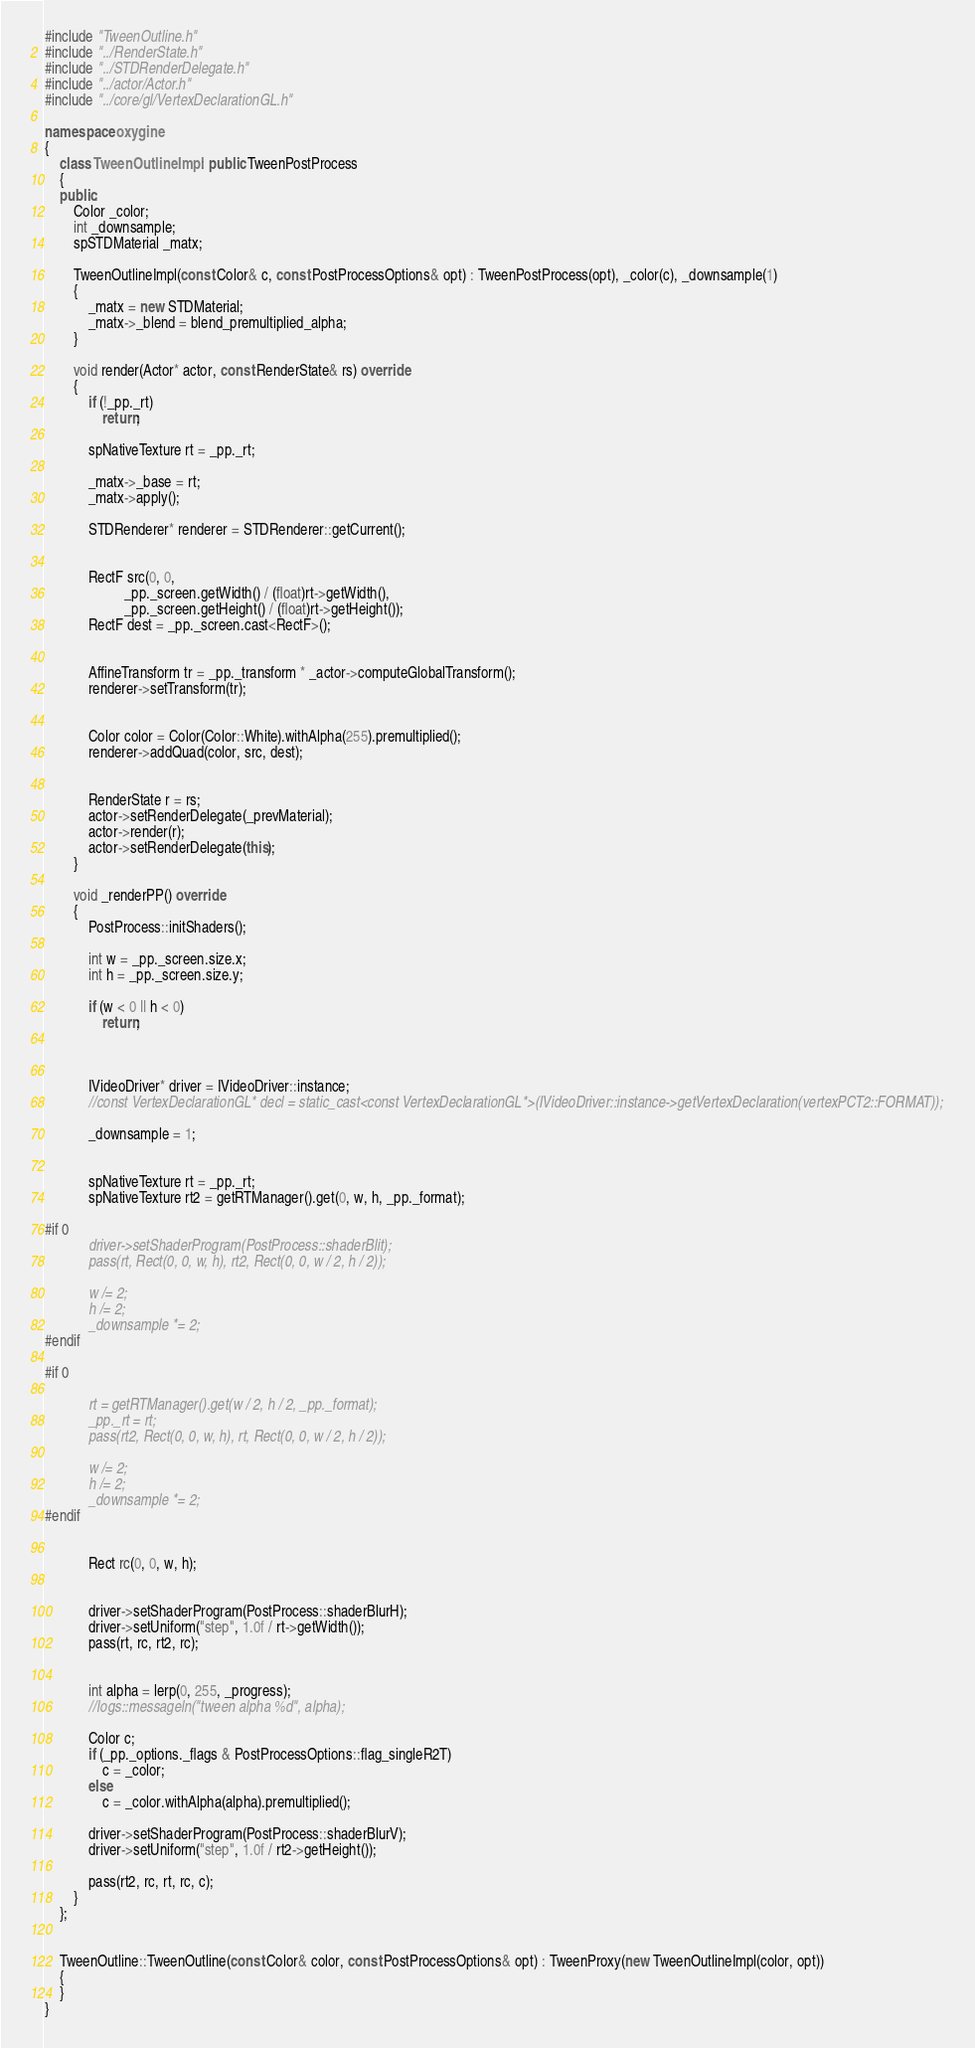<code> <loc_0><loc_0><loc_500><loc_500><_C++_>#include "TweenOutline.h"
#include "../RenderState.h"
#include "../STDRenderDelegate.h"
#include "../actor/Actor.h"
#include "../core/gl/VertexDeclarationGL.h"

namespace oxygine
{
    class TweenOutlineImpl : public TweenPostProcess
    {
    public:
        Color _color;
        int _downsample;
        spSTDMaterial _matx;

        TweenOutlineImpl(const Color& c, const PostProcessOptions& opt) : TweenPostProcess(opt), _color(c), _downsample(1)
        {
            _matx = new STDMaterial;
            _matx->_blend = blend_premultiplied_alpha;
        }

        void render(Actor* actor, const RenderState& rs) override
        {
            if (!_pp._rt)
                return;

            spNativeTexture rt = _pp._rt;

            _matx->_base = rt;
            _matx->apply();

            STDRenderer* renderer = STDRenderer::getCurrent();


            RectF src(0, 0,
                      _pp._screen.getWidth() / (float)rt->getWidth(),
                      _pp._screen.getHeight() / (float)rt->getHeight());
            RectF dest = _pp._screen.cast<RectF>();


            AffineTransform tr = _pp._transform * _actor->computeGlobalTransform();
            renderer->setTransform(tr);


            Color color = Color(Color::White).withAlpha(255).premultiplied();
            renderer->addQuad(color, src, dest);


            RenderState r = rs;
            actor->setRenderDelegate(_prevMaterial);
            actor->render(r);
            actor->setRenderDelegate(this);
        }

        void _renderPP() override
        {
            PostProcess::initShaders();

            int w = _pp._screen.size.x;
            int h = _pp._screen.size.y;

            if (w < 0 || h < 0)
                return;



            IVideoDriver* driver = IVideoDriver::instance;
            //const VertexDeclarationGL* decl = static_cast<const VertexDeclarationGL*>(IVideoDriver::instance->getVertexDeclaration(vertexPCT2::FORMAT));

            _downsample = 1;


            spNativeTexture rt = _pp._rt;
            spNativeTexture rt2 = getRTManager().get(0, w, h, _pp._format);

#if 0
            driver->setShaderProgram(PostProcess::shaderBlit);
            pass(rt, Rect(0, 0, w, h), rt2, Rect(0, 0, w / 2, h / 2));

            w /= 2;
            h /= 2;
            _downsample *= 2;
#endif

#if 0

            rt = getRTManager().get(w / 2, h / 2, _pp._format);
            _pp._rt = rt;
            pass(rt2, Rect(0, 0, w, h), rt, Rect(0, 0, w / 2, h / 2));

            w /= 2;
            h /= 2;
            _downsample *= 2;
#endif


            Rect rc(0, 0, w, h);


            driver->setShaderProgram(PostProcess::shaderBlurH);
            driver->setUniform("step", 1.0f / rt->getWidth());
            pass(rt, rc, rt2, rc);


            int alpha = lerp(0, 255, _progress);
            //logs::messageln("tween alpha %d", alpha);

            Color c;
            if (_pp._options._flags & PostProcessOptions::flag_singleR2T)
                c = _color;
            else
                c = _color.withAlpha(alpha).premultiplied();

            driver->setShaderProgram(PostProcess::shaderBlurV);
            driver->setUniform("step", 1.0f / rt2->getHeight());

            pass(rt2, rc, rt, rc, c);
        }
    };


    TweenOutline::TweenOutline(const Color& color, const PostProcessOptions& opt) : TweenProxy(new TweenOutlineImpl(color, opt))
    {
    }
}</code> 